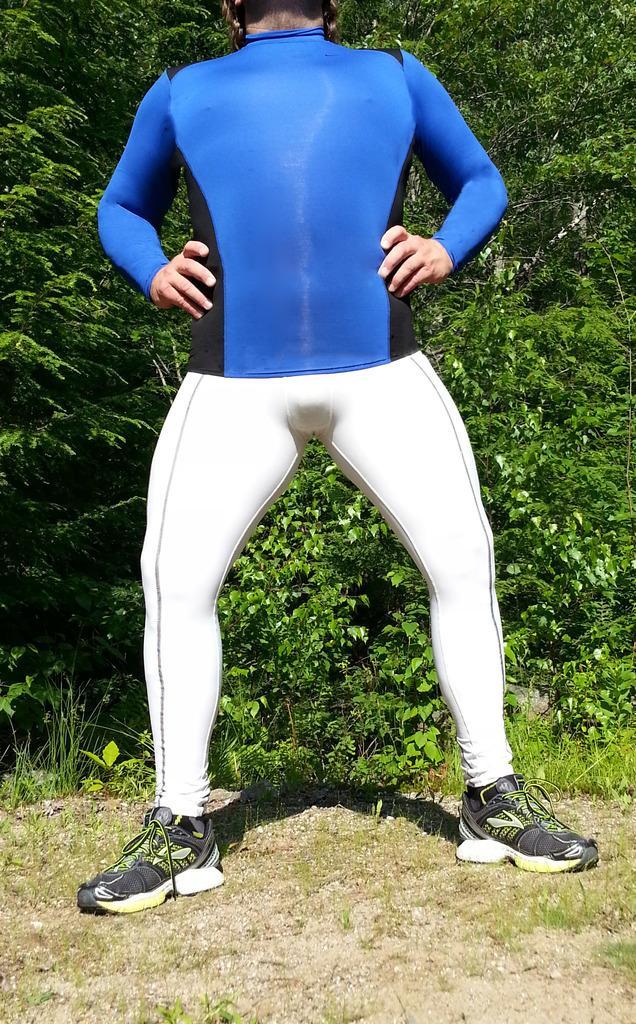Describe this image in one or two sentences. In the image there is a person in blue t-shirt and white pants and sports shoe standing on the grassland, behind him there are plants. 